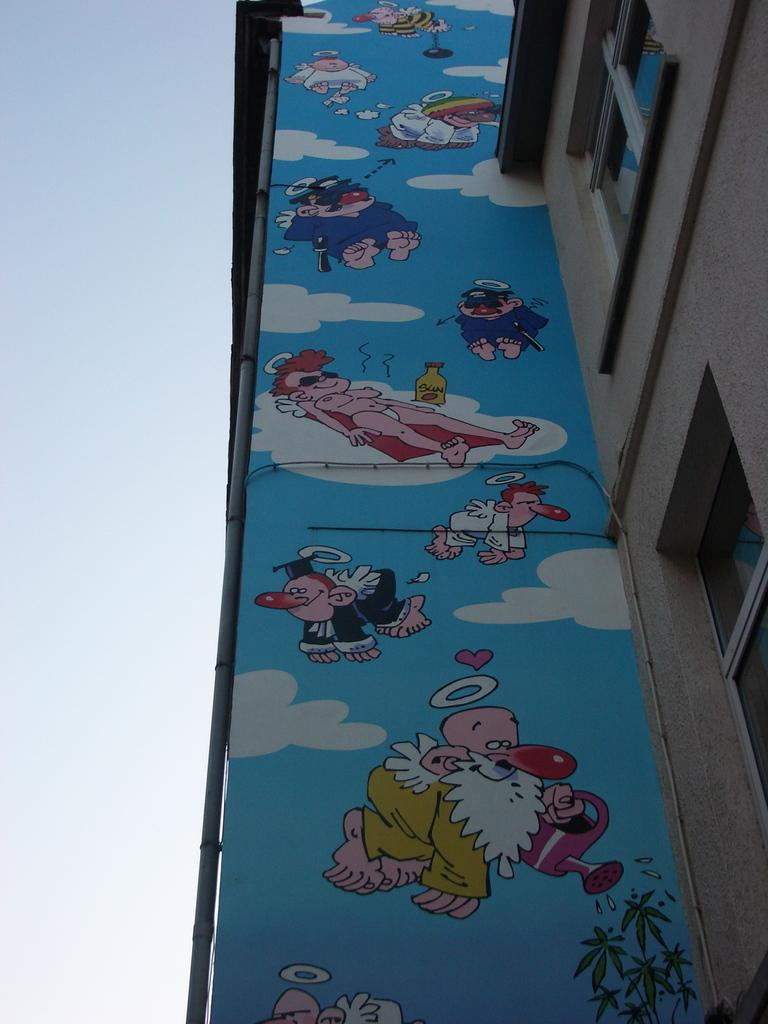What type of structure is visible in the image? There is a building with windows in the image. What can be seen on the wall inside the building? There is a painting of animated characters on the wall in the image. What else is present on the wall in the image? There is a pipe on the wall in the image. What is visible on the left side of the image? The sky is visible on the left side of the image. How many mice are hiding behind the pipe in the image? There are no mice present in the image. What type of marble is used for the floor in the image? There is no mention of marble or flooring in the image. --- Facts: 1. There is a person sitting on a chair in the image. 2. The person is holding a book. 3. There is a table next to the chair. 4. There is a lamp on the table. 5. The background of the image is a room with a bookshelf. Absurd Topics: elephant, ocean, bicycle Conversation: What is the person in the image doing? The person is sitting on a chair in the image. What is the person holding in the image? The person is holding a book in the image. What is located next to the chair in the image? There is a table next to the chair in the image. What is on the table in the image? There is a lamp on the table in the image. What can be seen in the background of the image? The background of the image is a room with a bookshelf. Reasoning: Let's think step by step in order to produce the conversation. We start by identifying the main subject in the image, which is the person sitting on a chair. Then, we describe what the person is holding and what is located next to the chair. We also mention the lamp on the table and the bookshelf in the background. Each question is designed to elicit a specific detail about the image that is known from the provided facts. Absurd Question/Answer: Can you see an elephant swimming in the ocean in the image? No, there is no elephant or ocean present in the image. Is the person riding a bicycle in the image? No, the person is sitting on a chair and not riding a bicycle in the image. 